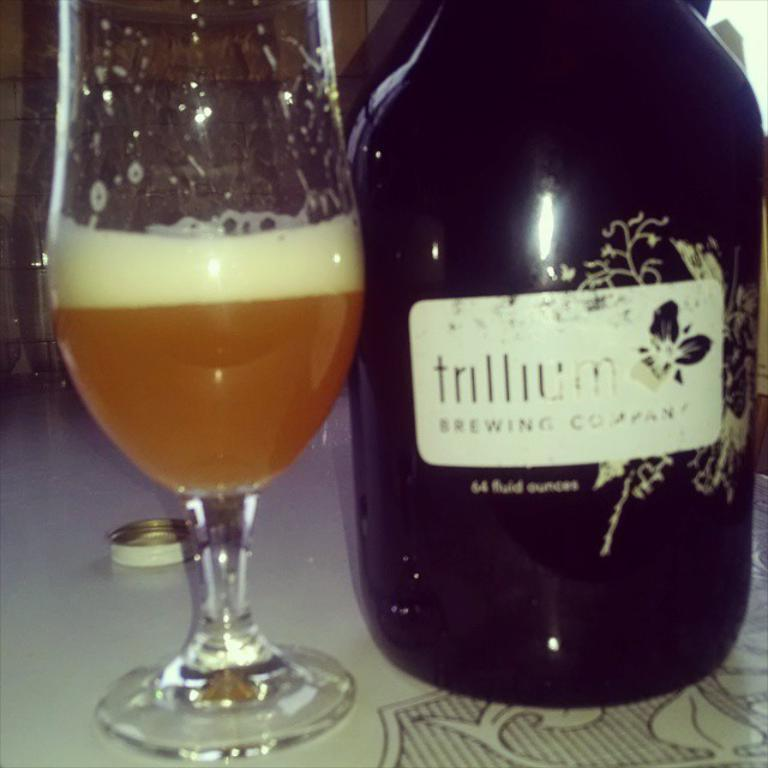<image>
Provide a brief description of the given image. A glass of liquid is next to a bottle that has the word brewing on it 